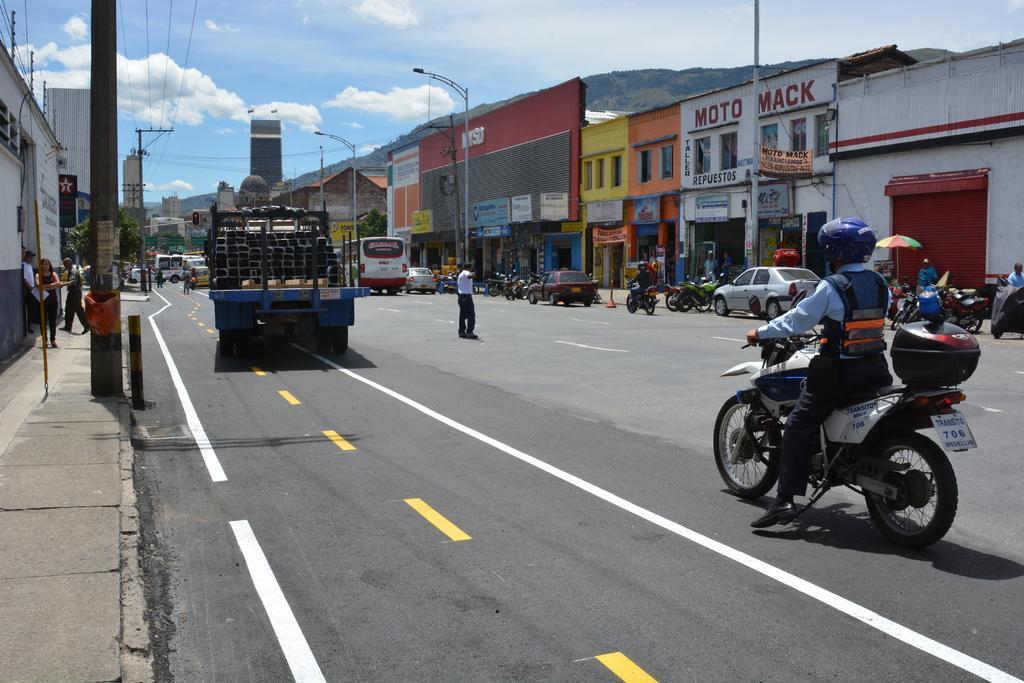In one or two sentences, can you explain what this image depicts? In this picture there are few vehicles on the road and there is a person standing in the middle of the road and there are few poles and buildings on either sides of it and there is a mountain in the background. 